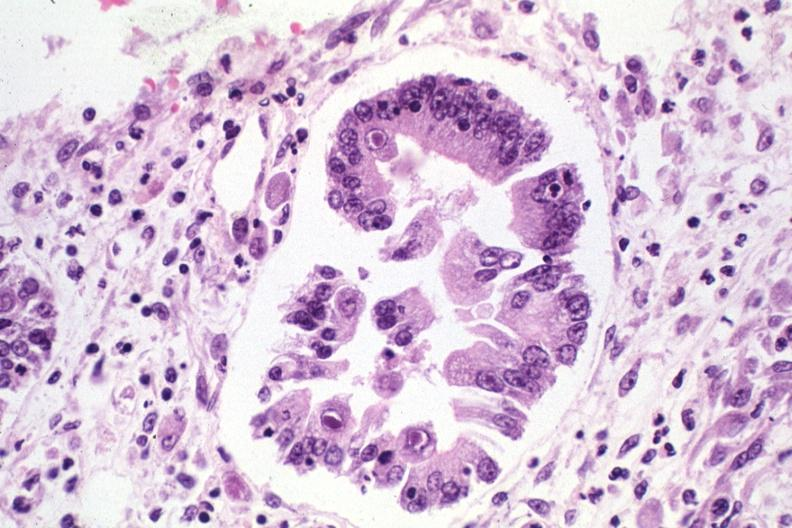where is this from?
Answer the question using a single word or phrase. Gastrointestinal system 